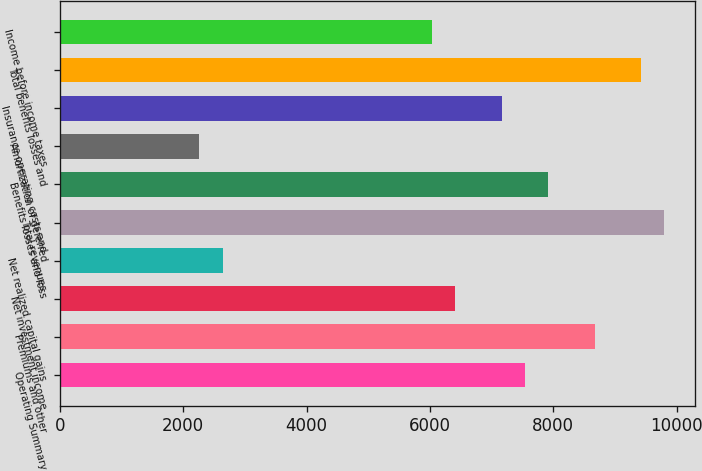Convert chart to OTSL. <chart><loc_0><loc_0><loc_500><loc_500><bar_chart><fcel>Operating Summary<fcel>Premiums and other<fcel>Net investment income<fcel>Net realized capital gains<fcel>Total revenues<fcel>Benefits losses and loss<fcel>Amortization of deferred<fcel>Insurance operating costs and<fcel>Total benefits losses and<fcel>Income before income taxes<nl><fcel>7539.2<fcel>8669.96<fcel>6408.44<fcel>2639.24<fcel>9800.72<fcel>7916.12<fcel>2262.32<fcel>7162.28<fcel>9423.8<fcel>6031.52<nl></chart> 